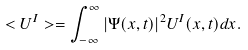<formula> <loc_0><loc_0><loc_500><loc_500>< U ^ { I } > = \int _ { - \infty } ^ { \infty } | \Psi ( x , t ) | ^ { 2 } U ^ { I } ( x , t ) d x .</formula> 